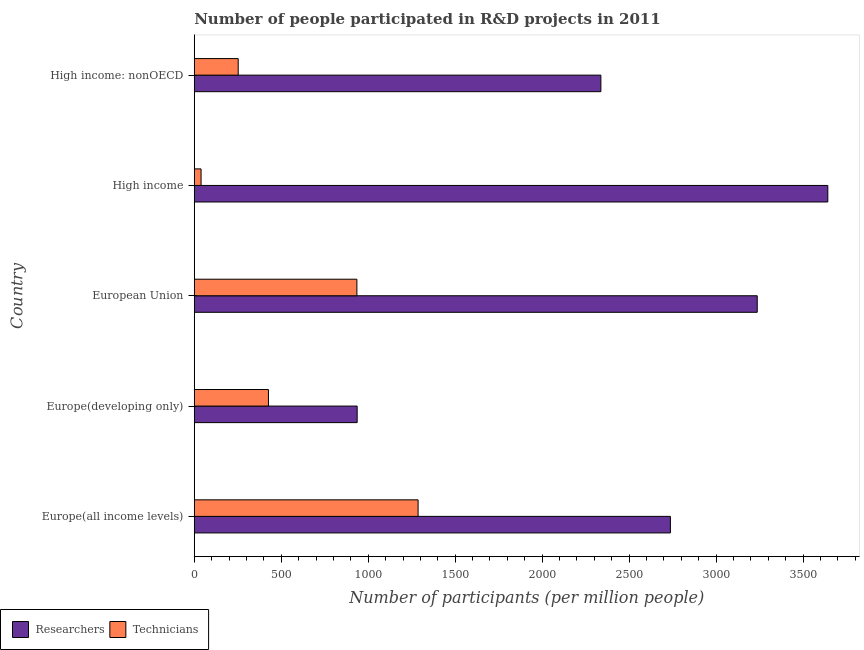How many groups of bars are there?
Offer a terse response. 5. Are the number of bars per tick equal to the number of legend labels?
Provide a succinct answer. Yes. How many bars are there on the 1st tick from the top?
Provide a short and direct response. 2. What is the label of the 4th group of bars from the top?
Provide a succinct answer. Europe(developing only). What is the number of researchers in Europe(developing only)?
Provide a succinct answer. 936.45. Across all countries, what is the maximum number of technicians?
Your response must be concise. 1286.74. Across all countries, what is the minimum number of technicians?
Provide a short and direct response. 39.1. In which country was the number of technicians maximum?
Keep it short and to the point. Europe(all income levels). In which country was the number of technicians minimum?
Make the answer very short. High income. What is the total number of technicians in the graph?
Your answer should be compact. 2939.75. What is the difference between the number of technicians in European Union and that in High income?
Offer a very short reply. 895.75. What is the difference between the number of technicians in High income and the number of researchers in European Union?
Make the answer very short. -3197.24. What is the average number of technicians per country?
Ensure brevity in your answer.  587.95. What is the difference between the number of technicians and number of researchers in European Union?
Offer a terse response. -2301.49. In how many countries, is the number of technicians greater than 2000 ?
Provide a short and direct response. 0. What is the ratio of the number of technicians in Europe(all income levels) to that in Europe(developing only)?
Your response must be concise. 3.02. Is the number of technicians in Europe(developing only) less than that in High income?
Your answer should be compact. No. Is the difference between the number of researchers in European Union and High income: nonOECD greater than the difference between the number of technicians in European Union and High income: nonOECD?
Make the answer very short. Yes. What is the difference between the highest and the second highest number of technicians?
Offer a terse response. 351.89. What is the difference between the highest and the lowest number of technicians?
Provide a succinct answer. 1247.64. Is the sum of the number of technicians in Europe(developing only) and European Union greater than the maximum number of researchers across all countries?
Ensure brevity in your answer.  No. What does the 2nd bar from the top in Europe(all income levels) represents?
Provide a succinct answer. Researchers. What does the 1st bar from the bottom in Europe(all income levels) represents?
Provide a short and direct response. Researchers. How many countries are there in the graph?
Your answer should be very brief. 5. Does the graph contain grids?
Offer a terse response. No. How are the legend labels stacked?
Keep it short and to the point. Horizontal. What is the title of the graph?
Make the answer very short. Number of people participated in R&D projects in 2011. Does "Researchers" appear as one of the legend labels in the graph?
Your answer should be very brief. Yes. What is the label or title of the X-axis?
Make the answer very short. Number of participants (per million people). What is the Number of participants (per million people) of Researchers in Europe(all income levels)?
Ensure brevity in your answer.  2737.14. What is the Number of participants (per million people) in Technicians in Europe(all income levels)?
Make the answer very short. 1286.74. What is the Number of participants (per million people) of Researchers in Europe(developing only)?
Give a very brief answer. 936.45. What is the Number of participants (per million people) in Technicians in Europe(developing only)?
Ensure brevity in your answer.  426.47. What is the Number of participants (per million people) of Researchers in European Union?
Keep it short and to the point. 3236.35. What is the Number of participants (per million people) in Technicians in European Union?
Ensure brevity in your answer.  934.85. What is the Number of participants (per million people) of Researchers in High income?
Provide a short and direct response. 3642.07. What is the Number of participants (per million people) in Technicians in High income?
Provide a short and direct response. 39.1. What is the Number of participants (per million people) in Researchers in High income: nonOECD?
Your answer should be compact. 2337.46. What is the Number of participants (per million people) of Technicians in High income: nonOECD?
Ensure brevity in your answer.  252.58. Across all countries, what is the maximum Number of participants (per million people) in Researchers?
Offer a terse response. 3642.07. Across all countries, what is the maximum Number of participants (per million people) in Technicians?
Offer a very short reply. 1286.74. Across all countries, what is the minimum Number of participants (per million people) of Researchers?
Your answer should be compact. 936.45. Across all countries, what is the minimum Number of participants (per million people) in Technicians?
Your answer should be compact. 39.1. What is the total Number of participants (per million people) in Researchers in the graph?
Keep it short and to the point. 1.29e+04. What is the total Number of participants (per million people) of Technicians in the graph?
Ensure brevity in your answer.  2939.75. What is the difference between the Number of participants (per million people) of Researchers in Europe(all income levels) and that in Europe(developing only)?
Provide a short and direct response. 1800.68. What is the difference between the Number of participants (per million people) of Technicians in Europe(all income levels) and that in Europe(developing only)?
Ensure brevity in your answer.  860.28. What is the difference between the Number of participants (per million people) of Researchers in Europe(all income levels) and that in European Union?
Offer a very short reply. -499.21. What is the difference between the Number of participants (per million people) in Technicians in Europe(all income levels) and that in European Union?
Provide a succinct answer. 351.89. What is the difference between the Number of participants (per million people) of Researchers in Europe(all income levels) and that in High income?
Provide a short and direct response. -904.94. What is the difference between the Number of participants (per million people) of Technicians in Europe(all income levels) and that in High income?
Offer a terse response. 1247.64. What is the difference between the Number of participants (per million people) of Researchers in Europe(all income levels) and that in High income: nonOECD?
Your response must be concise. 399.67. What is the difference between the Number of participants (per million people) of Technicians in Europe(all income levels) and that in High income: nonOECD?
Keep it short and to the point. 1034.17. What is the difference between the Number of participants (per million people) in Researchers in Europe(developing only) and that in European Union?
Provide a short and direct response. -2299.9. What is the difference between the Number of participants (per million people) in Technicians in Europe(developing only) and that in European Union?
Your answer should be compact. -508.38. What is the difference between the Number of participants (per million people) of Researchers in Europe(developing only) and that in High income?
Offer a very short reply. -2705.62. What is the difference between the Number of participants (per million people) of Technicians in Europe(developing only) and that in High income?
Your response must be concise. 387.37. What is the difference between the Number of participants (per million people) in Researchers in Europe(developing only) and that in High income: nonOECD?
Your answer should be compact. -1401.01. What is the difference between the Number of participants (per million people) in Technicians in Europe(developing only) and that in High income: nonOECD?
Your answer should be very brief. 173.89. What is the difference between the Number of participants (per million people) of Researchers in European Union and that in High income?
Your response must be concise. -405.72. What is the difference between the Number of participants (per million people) in Technicians in European Union and that in High income?
Make the answer very short. 895.75. What is the difference between the Number of participants (per million people) of Researchers in European Union and that in High income: nonOECD?
Provide a succinct answer. 898.88. What is the difference between the Number of participants (per million people) of Technicians in European Union and that in High income: nonOECD?
Your response must be concise. 682.28. What is the difference between the Number of participants (per million people) in Researchers in High income and that in High income: nonOECD?
Offer a very short reply. 1304.61. What is the difference between the Number of participants (per million people) in Technicians in High income and that in High income: nonOECD?
Provide a succinct answer. -213.47. What is the difference between the Number of participants (per million people) of Researchers in Europe(all income levels) and the Number of participants (per million people) of Technicians in Europe(developing only)?
Offer a terse response. 2310.67. What is the difference between the Number of participants (per million people) in Researchers in Europe(all income levels) and the Number of participants (per million people) in Technicians in European Union?
Provide a succinct answer. 1802.28. What is the difference between the Number of participants (per million people) of Researchers in Europe(all income levels) and the Number of participants (per million people) of Technicians in High income?
Offer a terse response. 2698.03. What is the difference between the Number of participants (per million people) in Researchers in Europe(all income levels) and the Number of participants (per million people) in Technicians in High income: nonOECD?
Give a very brief answer. 2484.56. What is the difference between the Number of participants (per million people) in Researchers in Europe(developing only) and the Number of participants (per million people) in Technicians in European Union?
Provide a short and direct response. 1.6. What is the difference between the Number of participants (per million people) of Researchers in Europe(developing only) and the Number of participants (per million people) of Technicians in High income?
Keep it short and to the point. 897.35. What is the difference between the Number of participants (per million people) in Researchers in Europe(developing only) and the Number of participants (per million people) in Technicians in High income: nonOECD?
Give a very brief answer. 683.87. What is the difference between the Number of participants (per million people) in Researchers in European Union and the Number of participants (per million people) in Technicians in High income?
Your answer should be compact. 3197.24. What is the difference between the Number of participants (per million people) in Researchers in European Union and the Number of participants (per million people) in Technicians in High income: nonOECD?
Ensure brevity in your answer.  2983.77. What is the difference between the Number of participants (per million people) of Researchers in High income and the Number of participants (per million people) of Technicians in High income: nonOECD?
Offer a very short reply. 3389.49. What is the average Number of participants (per million people) of Researchers per country?
Offer a very short reply. 2577.89. What is the average Number of participants (per million people) in Technicians per country?
Your answer should be very brief. 587.95. What is the difference between the Number of participants (per million people) of Researchers and Number of participants (per million people) of Technicians in Europe(all income levels)?
Offer a very short reply. 1450.39. What is the difference between the Number of participants (per million people) of Researchers and Number of participants (per million people) of Technicians in Europe(developing only)?
Ensure brevity in your answer.  509.98. What is the difference between the Number of participants (per million people) of Researchers and Number of participants (per million people) of Technicians in European Union?
Ensure brevity in your answer.  2301.49. What is the difference between the Number of participants (per million people) in Researchers and Number of participants (per million people) in Technicians in High income?
Provide a short and direct response. 3602.97. What is the difference between the Number of participants (per million people) of Researchers and Number of participants (per million people) of Technicians in High income: nonOECD?
Give a very brief answer. 2084.89. What is the ratio of the Number of participants (per million people) of Researchers in Europe(all income levels) to that in Europe(developing only)?
Your answer should be very brief. 2.92. What is the ratio of the Number of participants (per million people) of Technicians in Europe(all income levels) to that in Europe(developing only)?
Ensure brevity in your answer.  3.02. What is the ratio of the Number of participants (per million people) of Researchers in Europe(all income levels) to that in European Union?
Offer a terse response. 0.85. What is the ratio of the Number of participants (per million people) of Technicians in Europe(all income levels) to that in European Union?
Keep it short and to the point. 1.38. What is the ratio of the Number of participants (per million people) in Researchers in Europe(all income levels) to that in High income?
Keep it short and to the point. 0.75. What is the ratio of the Number of participants (per million people) in Technicians in Europe(all income levels) to that in High income?
Provide a succinct answer. 32.91. What is the ratio of the Number of participants (per million people) in Researchers in Europe(all income levels) to that in High income: nonOECD?
Offer a terse response. 1.17. What is the ratio of the Number of participants (per million people) in Technicians in Europe(all income levels) to that in High income: nonOECD?
Make the answer very short. 5.09. What is the ratio of the Number of participants (per million people) of Researchers in Europe(developing only) to that in European Union?
Keep it short and to the point. 0.29. What is the ratio of the Number of participants (per million people) of Technicians in Europe(developing only) to that in European Union?
Offer a very short reply. 0.46. What is the ratio of the Number of participants (per million people) in Researchers in Europe(developing only) to that in High income?
Keep it short and to the point. 0.26. What is the ratio of the Number of participants (per million people) of Technicians in Europe(developing only) to that in High income?
Your answer should be very brief. 10.91. What is the ratio of the Number of participants (per million people) of Researchers in Europe(developing only) to that in High income: nonOECD?
Ensure brevity in your answer.  0.4. What is the ratio of the Number of participants (per million people) of Technicians in Europe(developing only) to that in High income: nonOECD?
Your response must be concise. 1.69. What is the ratio of the Number of participants (per million people) of Researchers in European Union to that in High income?
Provide a succinct answer. 0.89. What is the ratio of the Number of participants (per million people) in Technicians in European Union to that in High income?
Give a very brief answer. 23.91. What is the ratio of the Number of participants (per million people) in Researchers in European Union to that in High income: nonOECD?
Offer a very short reply. 1.38. What is the ratio of the Number of participants (per million people) in Technicians in European Union to that in High income: nonOECD?
Ensure brevity in your answer.  3.7. What is the ratio of the Number of participants (per million people) of Researchers in High income to that in High income: nonOECD?
Provide a succinct answer. 1.56. What is the ratio of the Number of participants (per million people) in Technicians in High income to that in High income: nonOECD?
Give a very brief answer. 0.15. What is the difference between the highest and the second highest Number of participants (per million people) in Researchers?
Your answer should be very brief. 405.72. What is the difference between the highest and the second highest Number of participants (per million people) of Technicians?
Offer a very short reply. 351.89. What is the difference between the highest and the lowest Number of participants (per million people) in Researchers?
Your answer should be compact. 2705.62. What is the difference between the highest and the lowest Number of participants (per million people) of Technicians?
Provide a succinct answer. 1247.64. 